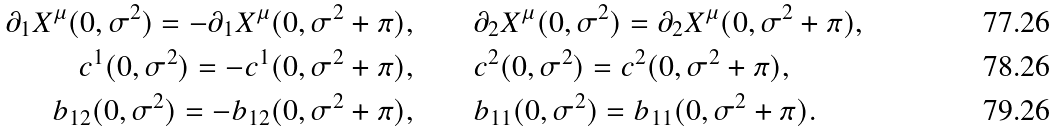<formula> <loc_0><loc_0><loc_500><loc_500>\partial _ { 1 } X ^ { \mu } ( 0 , \sigma ^ { 2 } ) = - \partial _ { 1 } X ^ { \mu } ( 0 , \sigma ^ { 2 } + \pi ) , \quad & \quad \partial _ { 2 } X ^ { \mu } ( 0 , \sigma ^ { 2 } ) = \partial _ { 2 } X ^ { \mu } ( 0 , \sigma ^ { 2 } + \pi ) , \\ c ^ { 1 } ( 0 , \sigma ^ { 2 } ) = - c ^ { 1 } ( 0 , \sigma ^ { 2 } + \pi ) , \quad & \quad c ^ { 2 } ( 0 , \sigma ^ { 2 } ) = c ^ { 2 } ( 0 , \sigma ^ { 2 } + \pi ) , \\ b _ { 1 2 } ( 0 , \sigma ^ { 2 } ) = - b _ { 1 2 } ( 0 , \sigma ^ { 2 } + \pi ) , \quad & \quad b _ { 1 1 } ( 0 , \sigma ^ { 2 } ) = b _ { 1 1 } ( 0 , \sigma ^ { 2 } + \pi ) .</formula> 